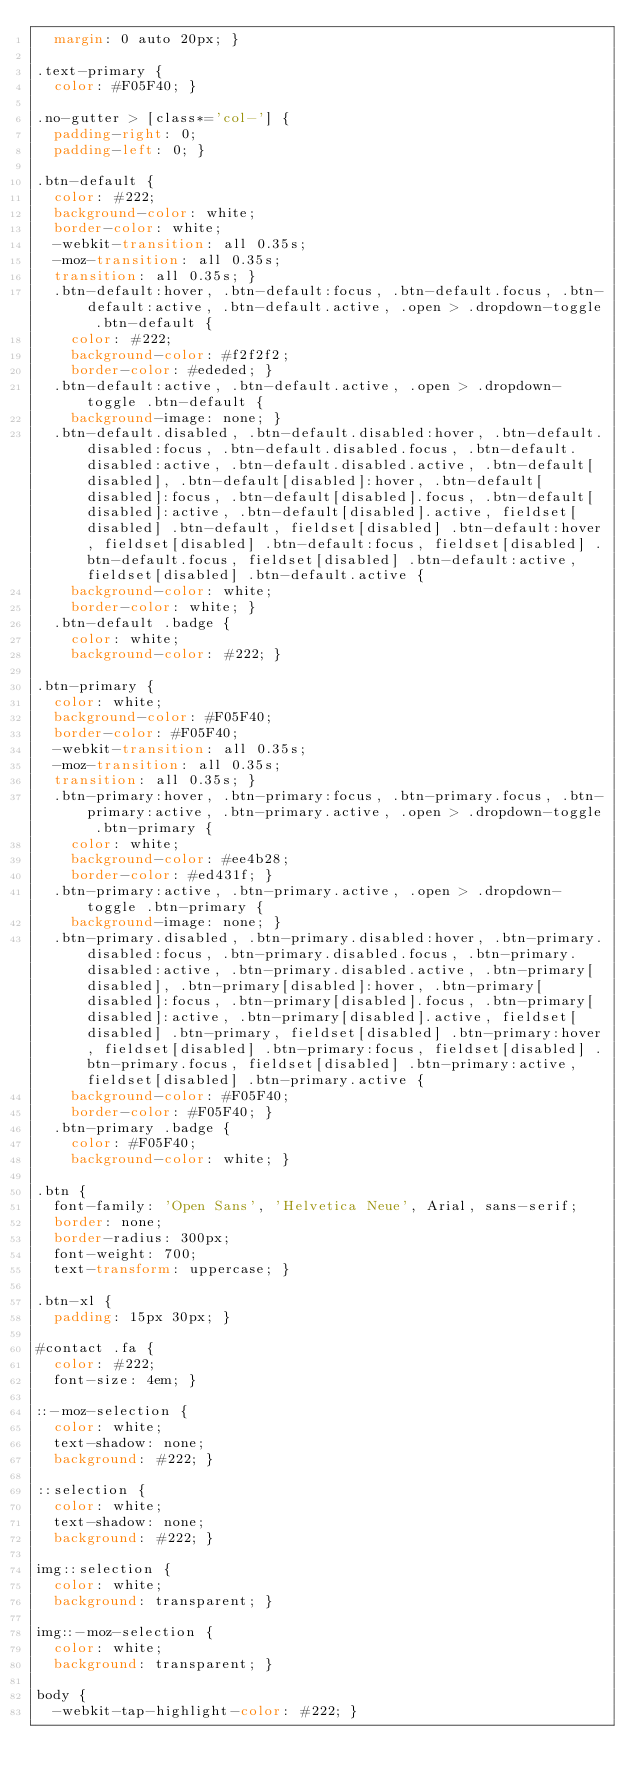<code> <loc_0><loc_0><loc_500><loc_500><_CSS_>  margin: 0 auto 20px; }

.text-primary {
  color: #F05F40; }

.no-gutter > [class*='col-'] {
  padding-right: 0;
  padding-left: 0; }

.btn-default {
  color: #222;
  background-color: white;
  border-color: white;
  -webkit-transition: all 0.35s;
  -moz-transition: all 0.35s;
  transition: all 0.35s; }
  .btn-default:hover, .btn-default:focus, .btn-default.focus, .btn-default:active, .btn-default.active, .open > .dropdown-toggle .btn-default {
    color: #222;
    background-color: #f2f2f2;
    border-color: #ededed; }
  .btn-default:active, .btn-default.active, .open > .dropdown-toggle .btn-default {
    background-image: none; }
  .btn-default.disabled, .btn-default.disabled:hover, .btn-default.disabled:focus, .btn-default.disabled.focus, .btn-default.disabled:active, .btn-default.disabled.active, .btn-default[disabled], .btn-default[disabled]:hover, .btn-default[disabled]:focus, .btn-default[disabled].focus, .btn-default[disabled]:active, .btn-default[disabled].active, fieldset[disabled] .btn-default, fieldset[disabled] .btn-default:hover, fieldset[disabled] .btn-default:focus, fieldset[disabled] .btn-default.focus, fieldset[disabled] .btn-default:active, fieldset[disabled] .btn-default.active {
    background-color: white;
    border-color: white; }
  .btn-default .badge {
    color: white;
    background-color: #222; }

.btn-primary {
  color: white;
  background-color: #F05F40;
  border-color: #F05F40;
  -webkit-transition: all 0.35s;
  -moz-transition: all 0.35s;
  transition: all 0.35s; }
  .btn-primary:hover, .btn-primary:focus, .btn-primary.focus, .btn-primary:active, .btn-primary.active, .open > .dropdown-toggle .btn-primary {
    color: white;
    background-color: #ee4b28;
    border-color: #ed431f; }
  .btn-primary:active, .btn-primary.active, .open > .dropdown-toggle .btn-primary {
    background-image: none; }
  .btn-primary.disabled, .btn-primary.disabled:hover, .btn-primary.disabled:focus, .btn-primary.disabled.focus, .btn-primary.disabled:active, .btn-primary.disabled.active, .btn-primary[disabled], .btn-primary[disabled]:hover, .btn-primary[disabled]:focus, .btn-primary[disabled].focus, .btn-primary[disabled]:active, .btn-primary[disabled].active, fieldset[disabled] .btn-primary, fieldset[disabled] .btn-primary:hover, fieldset[disabled] .btn-primary:focus, fieldset[disabled] .btn-primary.focus, fieldset[disabled] .btn-primary:active, fieldset[disabled] .btn-primary.active {
    background-color: #F05F40;
    border-color: #F05F40; }
  .btn-primary .badge {
    color: #F05F40;
    background-color: white; }

.btn {
  font-family: 'Open Sans', 'Helvetica Neue', Arial, sans-serif;
  border: none;
  border-radius: 300px;
  font-weight: 700;
  text-transform: uppercase; }

.btn-xl {
  padding: 15px 30px; }

#contact .fa {
  color: #222;
  font-size: 4em; }

::-moz-selection {
  color: white;
  text-shadow: none;
  background: #222; }

::selection {
  color: white;
  text-shadow: none;
  background: #222; }

img::selection {
  color: white;
  background: transparent; }

img::-moz-selection {
  color: white;
  background: transparent; }

body {
  -webkit-tap-highlight-color: #222; }
</code> 